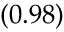<formula> <loc_0><loc_0><loc_500><loc_500>\left ( 0 . 9 8 \right )</formula> 